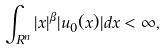<formula> <loc_0><loc_0><loc_500><loc_500>\int _ { R ^ { n } } | x | ^ { \beta } | u _ { 0 } ( x ) | d x < \infty ,</formula> 